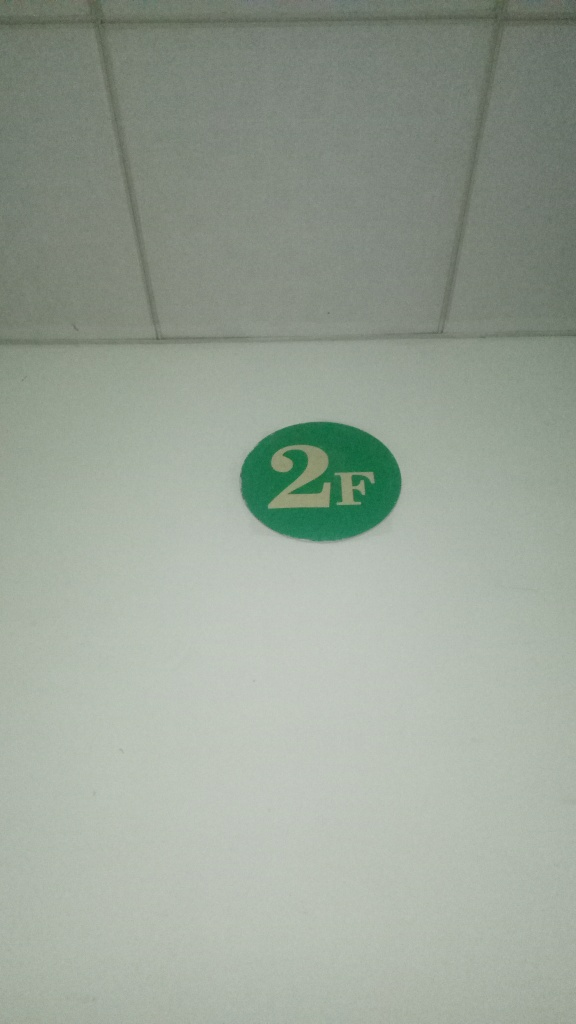The image appears to be taken in a poorly lit area. Can you suggest ways to improve the quality of such a photo? To improve the quality of a photo taken in a poorly lit area, one could increase the camera's ISO setting to make it more sensitive to light or use a slower shutter speed to allow more light to hit the sensor. Additionally, employing a flash or increasing the ambient lighting would also enhance the clarity and detail of the image. 